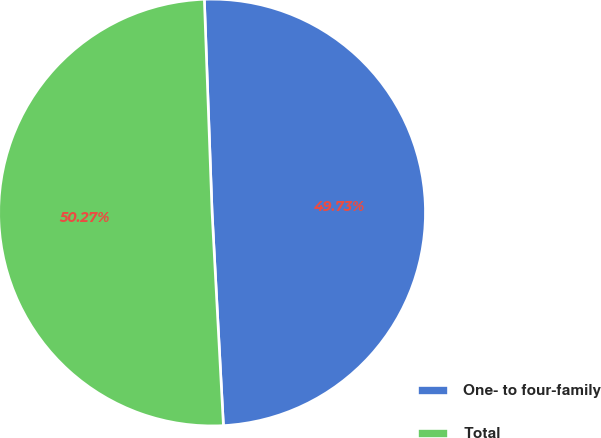<chart> <loc_0><loc_0><loc_500><loc_500><pie_chart><fcel>One- to four-family<fcel>Total<nl><fcel>49.73%<fcel>50.27%<nl></chart> 